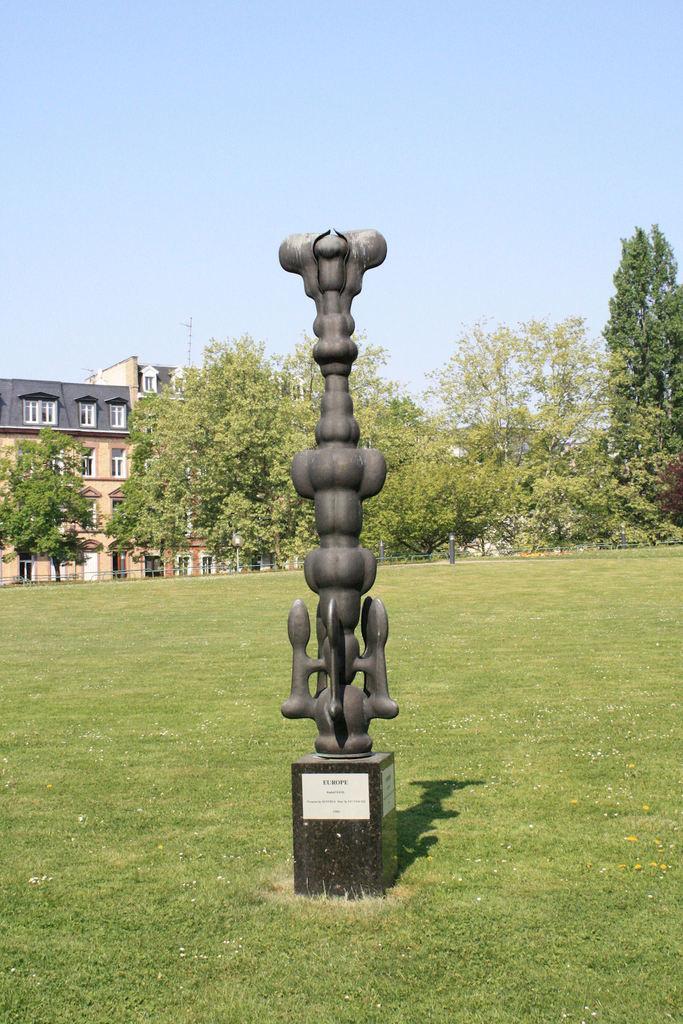Can you describe this image briefly? In this image we can see a statue, pedestal, trees, ground, buildings and sky. 